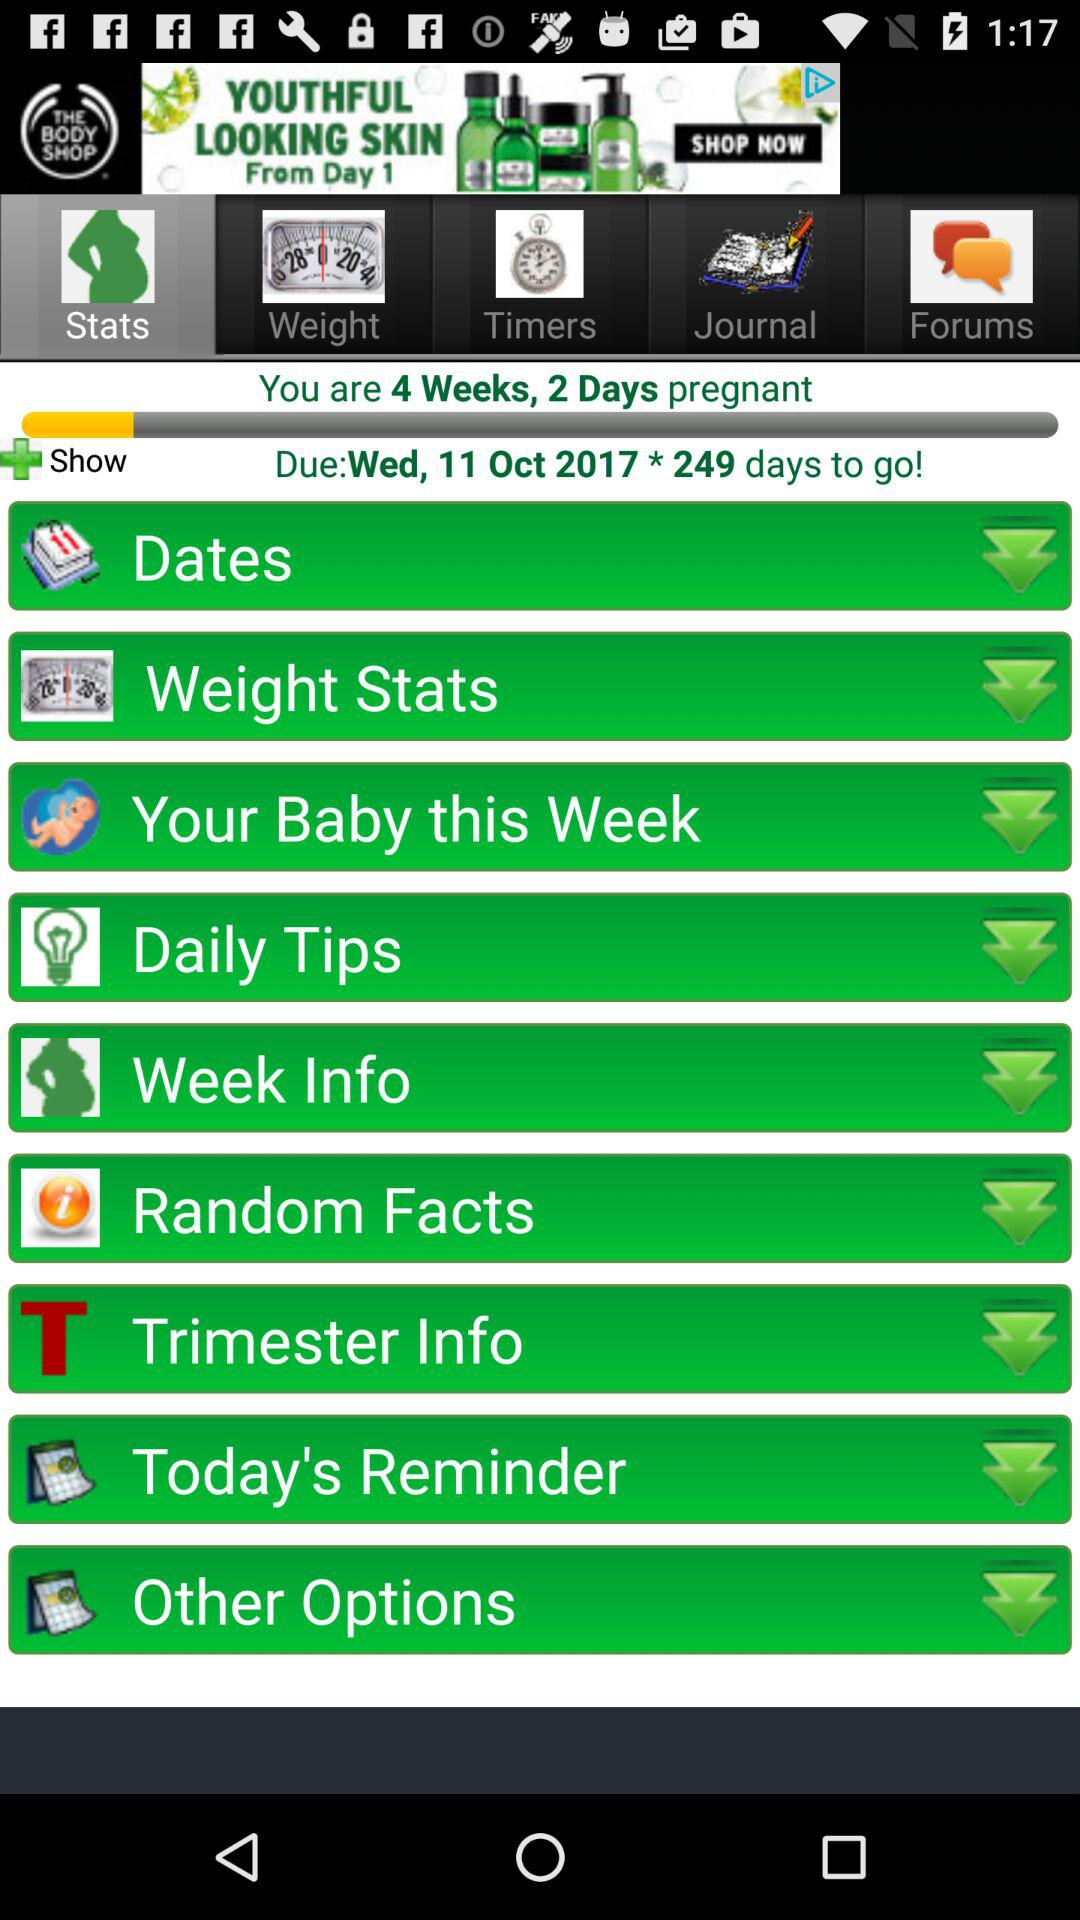Which option is selected? The selected option is "Stats". 